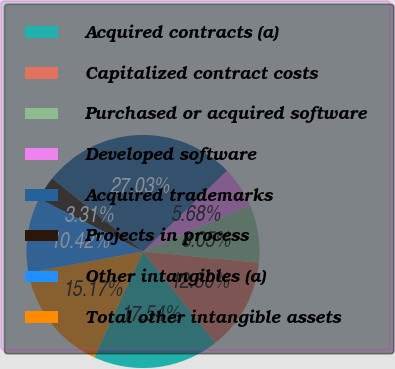Convert chart. <chart><loc_0><loc_0><loc_500><loc_500><pie_chart><fcel>Acquired contracts (a)<fcel>Capitalized contract costs<fcel>Purchased or acquired software<fcel>Developed software<fcel>Acquired trademarks<fcel>Projects in process<fcel>Other intangibles (a)<fcel>Total other intangible assets<nl><fcel>17.54%<fcel>12.8%<fcel>8.05%<fcel>5.68%<fcel>27.03%<fcel>3.31%<fcel>10.42%<fcel>15.17%<nl></chart> 